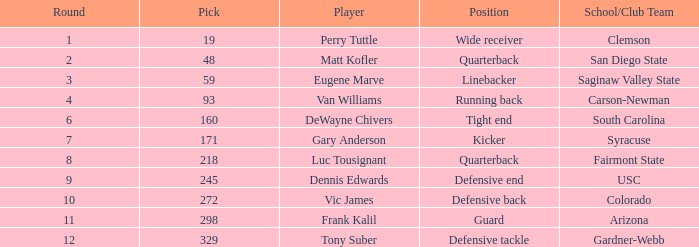Can you tell me who takes on the linebacker role? Eugene Marve. 